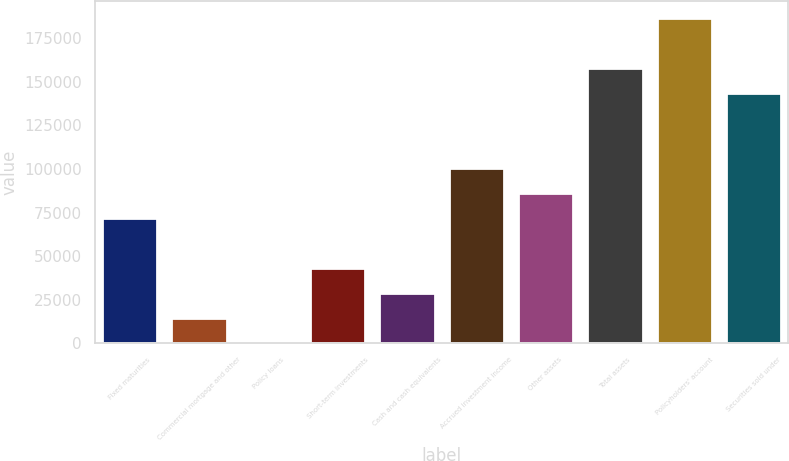Convert chart. <chart><loc_0><loc_0><loc_500><loc_500><bar_chart><fcel>Fixed maturities<fcel>Commercial mortgage and other<fcel>Policy loans<fcel>Short-term investments<fcel>Cash and cash equivalents<fcel>Accrued investment income<fcel>Other assets<fcel>Total assets<fcel>Policyholders' account<fcel>Securities sold under<nl><fcel>71889.2<fcel>14380.6<fcel>3.5<fcel>43134.9<fcel>28757.8<fcel>100644<fcel>86266.4<fcel>158152<fcel>186906<fcel>143775<nl></chart> 